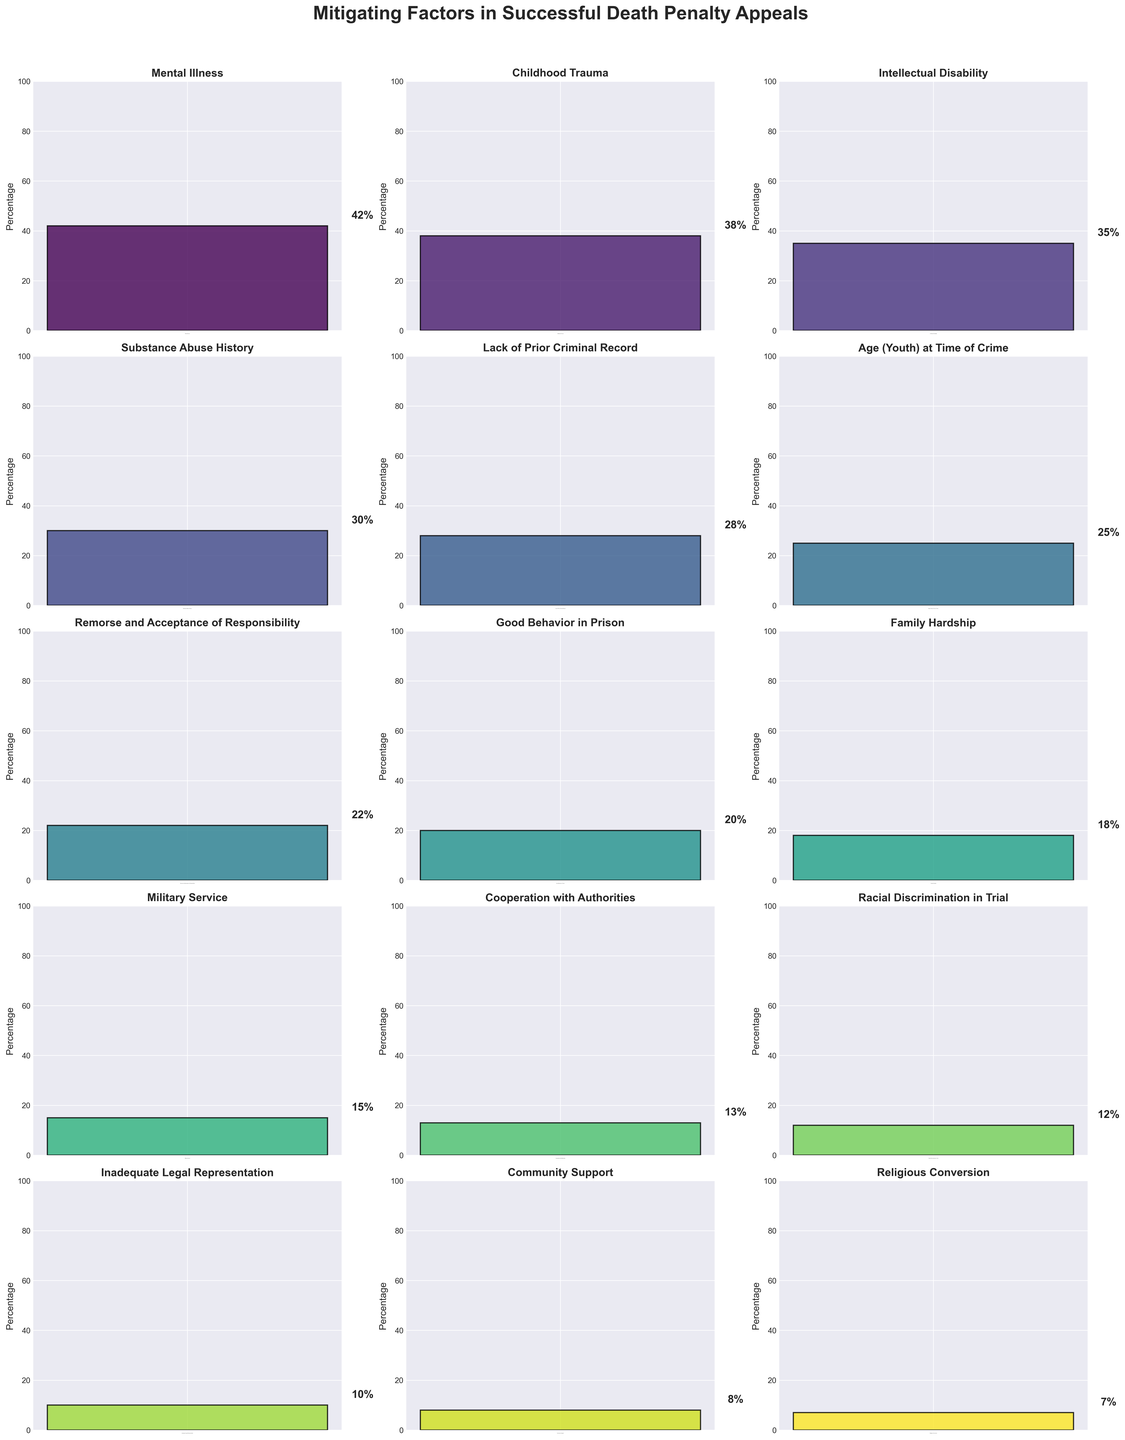What is the percentage of successful appeals that used Intellectual Disability as a mitigating factor? Locate the bar labeled "Intellectual Disability" in the figure. The percentage next to the bar indicates 35%.
Answer: 35% Which mitigating factor has the smallest percentage of successful appeals? Find the bar that is labeled with the smallest percentage. The bar labeled "Religious Conversion" has the smallest percentage at 7%.
Answer: Religious Conversion Is the percentage of successful appeals due to Mental Illness higher than those due to Substance Abuse History? Compare the height of the bar labeled "Mental Illness" (42%) with the bar labeled "Substance Abuse History" (30%). The percentage for Mental Illness is higher.
Answer: Yes By how many percentage points does the percentage for Mental Illness exceed the percentage for Lack of Prior Criminal Record? The percentage for Mental Illness is 42%, and for Lack of Prior Criminal Record, it is 28%. Subtract the latter from the former: 42% - 28% = 14 percentage points.
Answer: 14 percentage points What is the combined percentage of successful appeals due to Childhood Trauma and Inadequate Legal Representation? Locate the bars labeled "Childhood Trauma" (38%) and "Inadequate Legal Representation" (10%). Add these percentages together: 38% + 10% = 48%.
Answer: 48% Which mitigating factors have a percentage of successful appeals between 15% and 25% inclusive? Identify the bars with percentages within the range of 15% to 25%. These factors are Age (Youth) at Time of Crime (25%), Remorse and Acceptance of Responsibility (22%), Good Behavior in Prison (20%), and Family Hardship (18%).
Answer: Age at Time of Crime; Remorse and Acceptance of Responsibility; Good Behavior in Prison; Family Hardship Are there any mitigating factors with an equal percentage of successful appeals? Examine the figure to check if any bars have the same height/percentage. No two bars have the same percentage.
Answer: No What is the median percentage of successful appeals for all the mitigating factors? List all percentages: 42, 38, 35, 30, 28, 25, 22, 20, 18, 15, 13, 12, 10, 8, 7. Since there are 15 values, the median is the 8th value in the ordered list. The ordered list is 7, 8, 10, 12, 13, 15, 18, 20, 22, 25, 28, 30, 35, 38, 42. The median is therefore 20.
Answer: 20 How does the percentage for Military Service compare to the percentage for Racial Discrimination in Trial? Compare the heights of the bars for Military Service (15%) and Racial Discrimination in Trial (12%). The bar for Military Service is higher.
Answer: Higher What is the total percentage accounted for by the top three mitigating factors? The top three factors are Mental Illness (42%), Childhood Trauma (38%), and Intellectual Disability (35%). Add these percentages: 42% + 38% + 35% = 115%.
Answer: 115% 